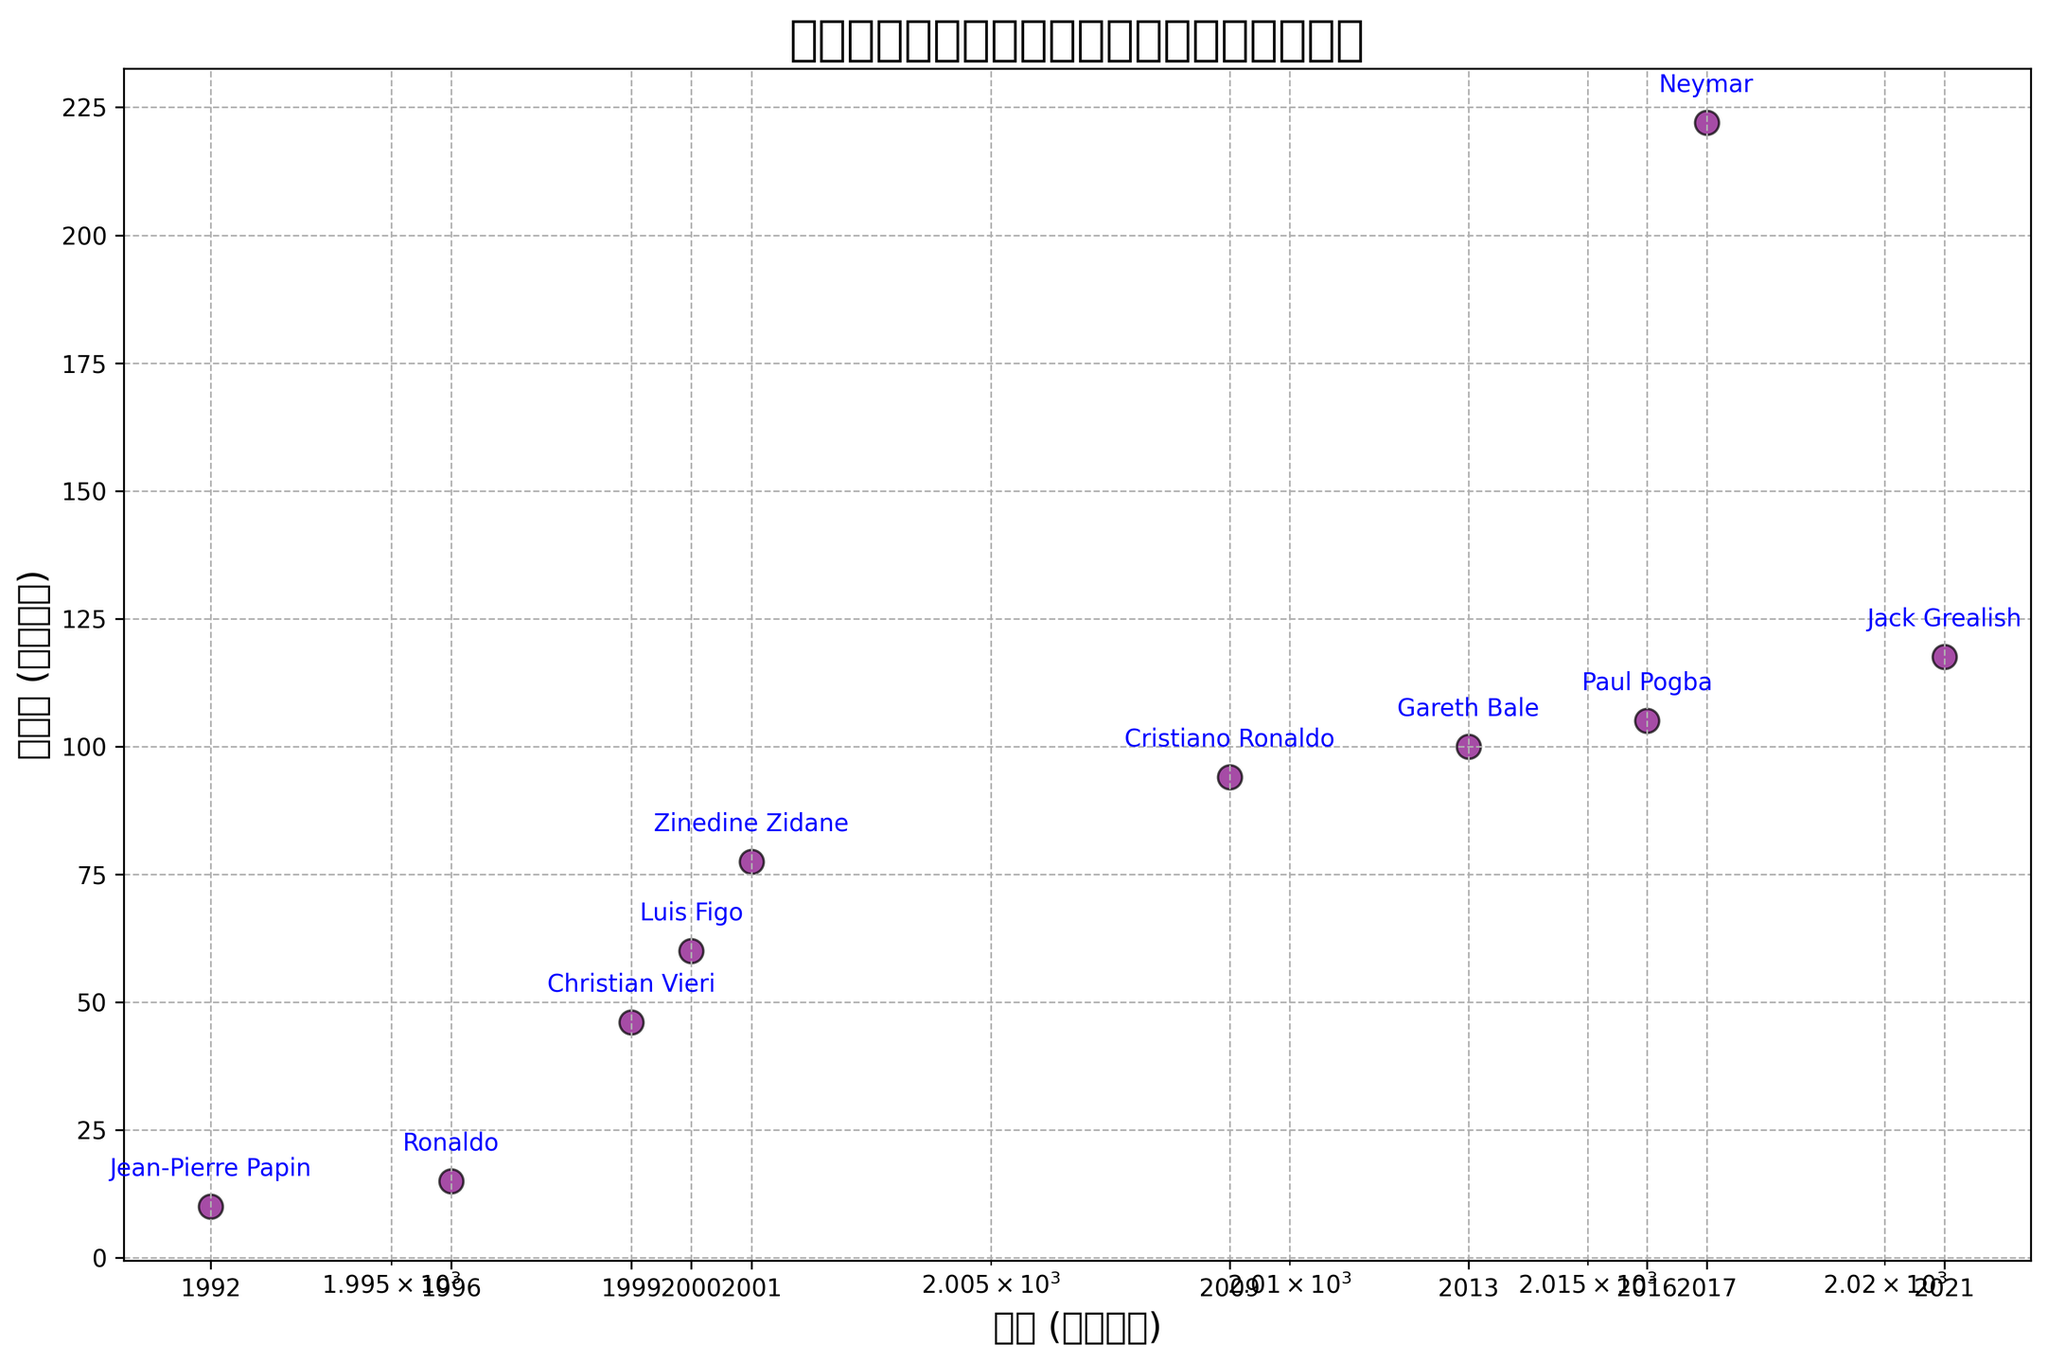what range of transfer fees is covered in the figure? The transfer fees range from 10 million euros (Jean-Pierre Papin in 1992) to 222 million euros (Neymar in 2017), so the range is 222 - 10 = 212 million euros.
Answer: 212 million euros Which player had the highest transfer fee, and what year was it? Neymar had the highest transfer fee of 222 million euros in 2017.
Answer: Neymar, 2017 What is the difference in transfer fees between Zinedine Zidane (2001) and Jack Grealish (2021)? Zinedine Zidane's transfer fee in 2001 was 77.5 million euros, and Jack Grealish's transfer fee in 2021 was 117.5 million euros. The difference is 117.5 - 77.5 = 40 million euros.
Answer: 40 million euros Which player had the lowest transfer fee and in what year? Jean-Pierre Papin had the lowest transfer fee of 10 million euros in 1992.
Answer: Jean-Pierre Papin, 1992 Compare the transfer fees of Cristiano Ronaldo (2009) and Gareth Bale (2013); which one was higher? Cristiano Ronaldo's transfer fee in 2009 was 94 million euros, and Gareth Bale's transfer fee in 2013 was 100 million euros. Gareth Bale's transfer fee was higher.
Answer: Gareth Bale How many years passed between Christian Vieri's transfer and Neymar's transfer? Christian Vieri was transferred in 1999, and Neymar was transferred in 2017. The number of years between their transfers is 2017 - 1999 = 18 years.
Answer: 18 years Calculate the average transfer fee for all players listed in the figure. Sum of all transfer fees is 10 + 15 + 46 + 60 + 77.5 + 94 + 100 + 105 + 222 + 117.5 = 847 million euros. There are 10 players, so the average transfer fee is 847 / 10 = 84.7 million euros.
Answer: 84.7 million euros Determine the percentage increase in transfer fee from Ronaldo (1996) to Cristiano Ronaldo (2009). Ronaldo's transfer fee in 1996 was 15 million euros, and Cristiano Ronaldo’s transfer fee in 2009 was 94 million euros. The percentage increase is ((94 - 15) / 15) * 100 = 526.67%.
Answer: 526.67% 